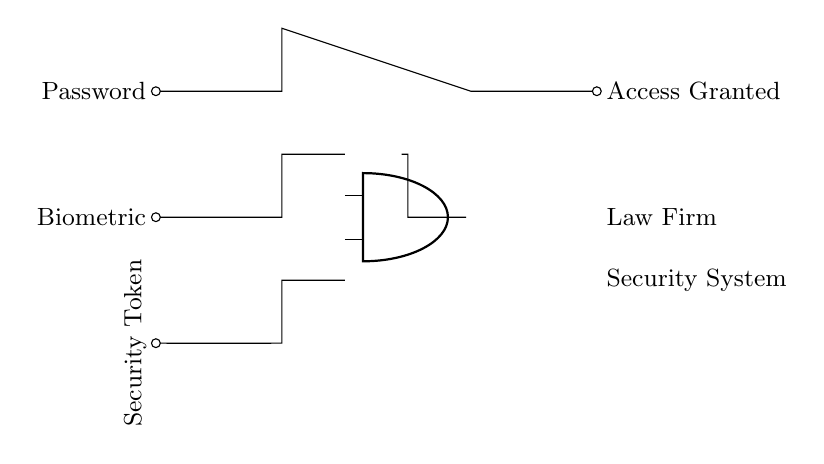What type of gate is used in this circuit? The circuit utilizes an AND gate, which is indicated by the shape and label "american and port." This gate requires all inputs to be true (or high) for the output to also be true.
Answer: AND gate How many inputs does the AND gate have? The AND gate in the circuit has three inputs: one from Password, one from Biometric, and one from Security Token. Each of these paths leads to the AND gate, contributing to the access decision.
Answer: Three inputs What outputs does the circuit provide? The circuit provides one output, which is labeled "Access Granted." This output signals whether access is permitted based on the conditions of the inputs feeding into the AND gate.
Answer: Access Granted What components are used as inputs to the AND gate? The components that serve as inputs to the AND gate are Password, Biometric, and Security Token. Each of these input components must meet their specific conditions for the AND gate to output access.
Answer: Password, Biometric, Security Token What logical condition must be met for access to be granted? For access to be granted, all three inputs (Password, Biometric, Security Token) must be present and correct. This is characteristic of the AND gate's function, as it only outputs high when all inputs are high.
Answer: All inputs must be true Why is an AND gate preferred for multi-factor authentication? An AND gate is preferred for multi-factor authentication because it ensures that multiple layers of security must be satisfied before access is granted. This increases security by requiring confirmation from all factors rather than just one.
Answer: Increased security 